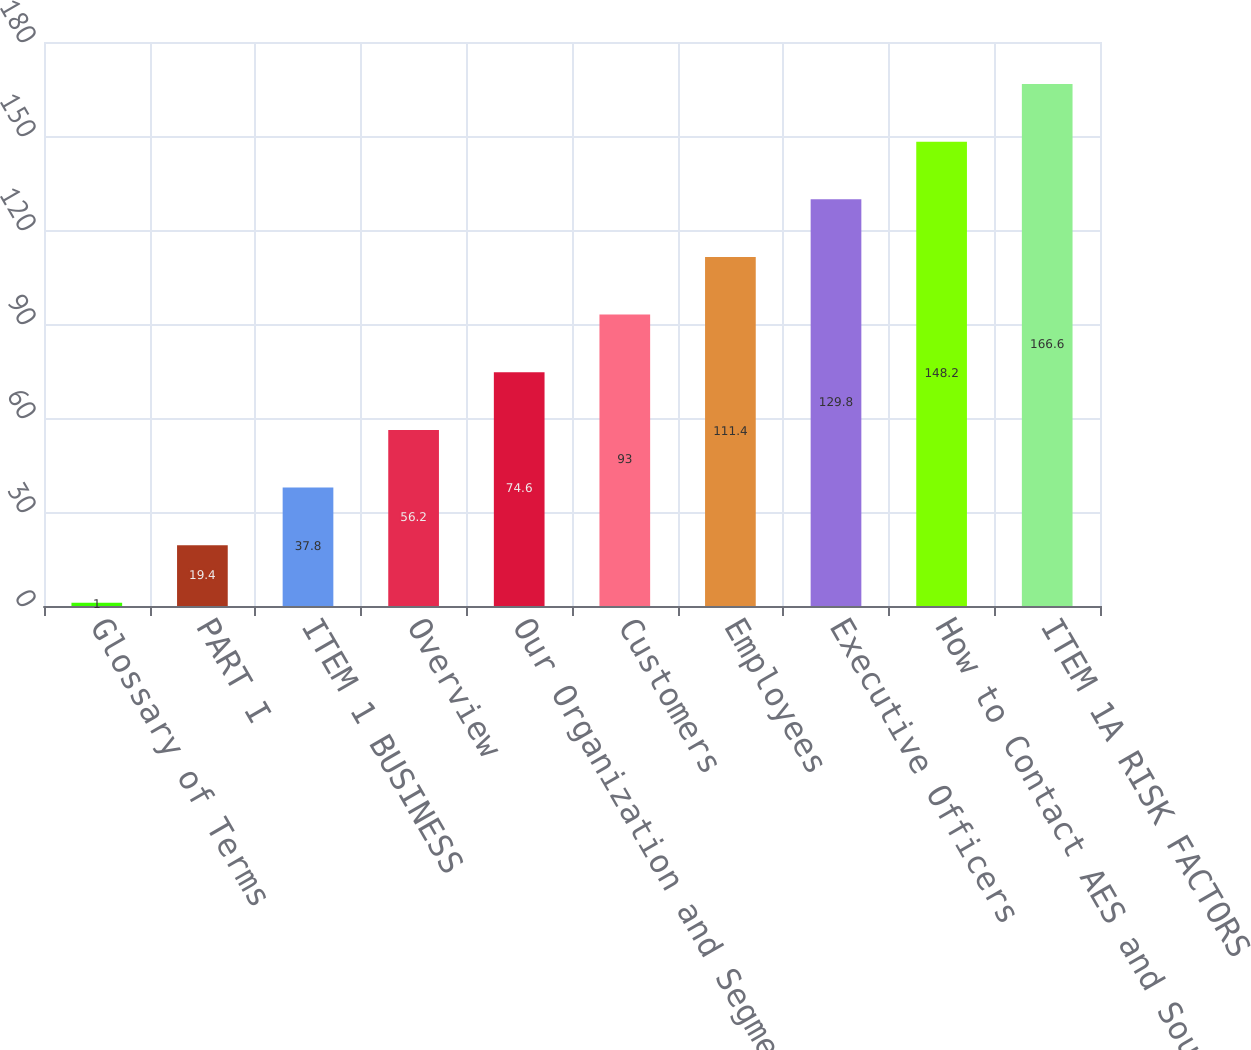<chart> <loc_0><loc_0><loc_500><loc_500><bar_chart><fcel>Glossary of Terms<fcel>PART I<fcel>ITEM 1 BUSINESS<fcel>Overview<fcel>Our Organization and Segments<fcel>Customers<fcel>Employees<fcel>Executive Officers<fcel>How to Contact AES and Sources<fcel>ITEM 1A RISK FACTORS<nl><fcel>1<fcel>19.4<fcel>37.8<fcel>56.2<fcel>74.6<fcel>93<fcel>111.4<fcel>129.8<fcel>148.2<fcel>166.6<nl></chart> 